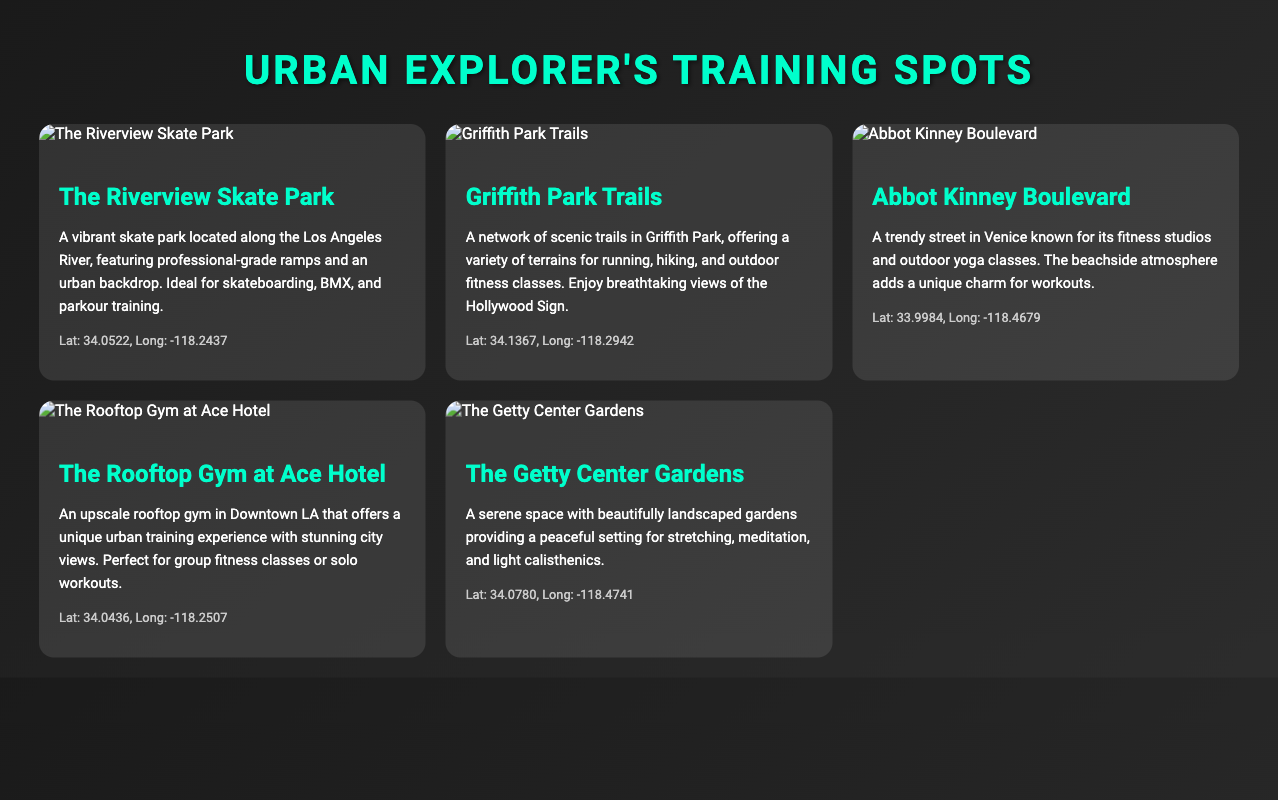What is the name of the skate park? The document mentions "The Riverview Skate Park" as a training spot with professional-grade ramps and an urban backdrop.
Answer: The Riverview Skate Park What is the latitude of Griffith Park Trails? The coordinates for Griffith Park Trails are given as 34.1367 (latitude) and -118.2942 (longitude).
Answer: 34.1367 Which training spot is located on Abbot Kinney Boulevard? "Abbot Kinney Boulevard" is described as a trendy street in Venice known for its fitness studios and outdoor yoga classes.
Answer: Abbot Kinney Boulevard How many training spots are featured in the document? The document lists five unique urban training locations.
Answer: Five What kind of training is ideal at The Getty Center Gardens? The Getty Center Gardens provides a serene space suitable for stretching, meditation, and light calisthenics.
Answer: Stretching, meditation, and light calisthenics What type of view can you expect at The Rooftop Gym at Ace Hotel? The Rooftop Gym at Ace Hotel offers stunning city views, enhancing the urban training experience.
Answer: Stunning city views Which location is best for parkour training? The description of "The Riverview Skate Park" highlights its suitability for skateboarding, BMX, and parkour training.
Answer: The Riverview Skate Park What unique atmosphere does Abbot Kinney Boulevard have? The document describes the beachside atmosphere of Abbot Kinney Boulevard as adding unique charm for workouts.
Answer: Beachside atmosphere 